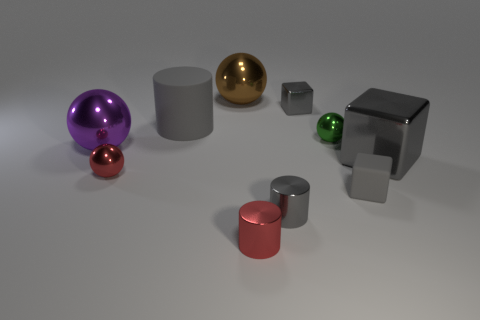Subtract all gray cylinders. How many cylinders are left? 1 Subtract all green balls. How many balls are left? 3 Subtract all cylinders. How many objects are left? 7 Subtract 3 spheres. How many spheres are left? 1 Subtract all yellow balls. How many gray cylinders are left? 2 Subtract all blue spheres. Subtract all cyan cylinders. How many spheres are left? 4 Subtract all tiny purple matte objects. Subtract all gray metallic blocks. How many objects are left? 8 Add 5 gray shiny cylinders. How many gray shiny cylinders are left? 6 Add 9 large red shiny cylinders. How many large red shiny cylinders exist? 9 Subtract 1 brown balls. How many objects are left? 9 